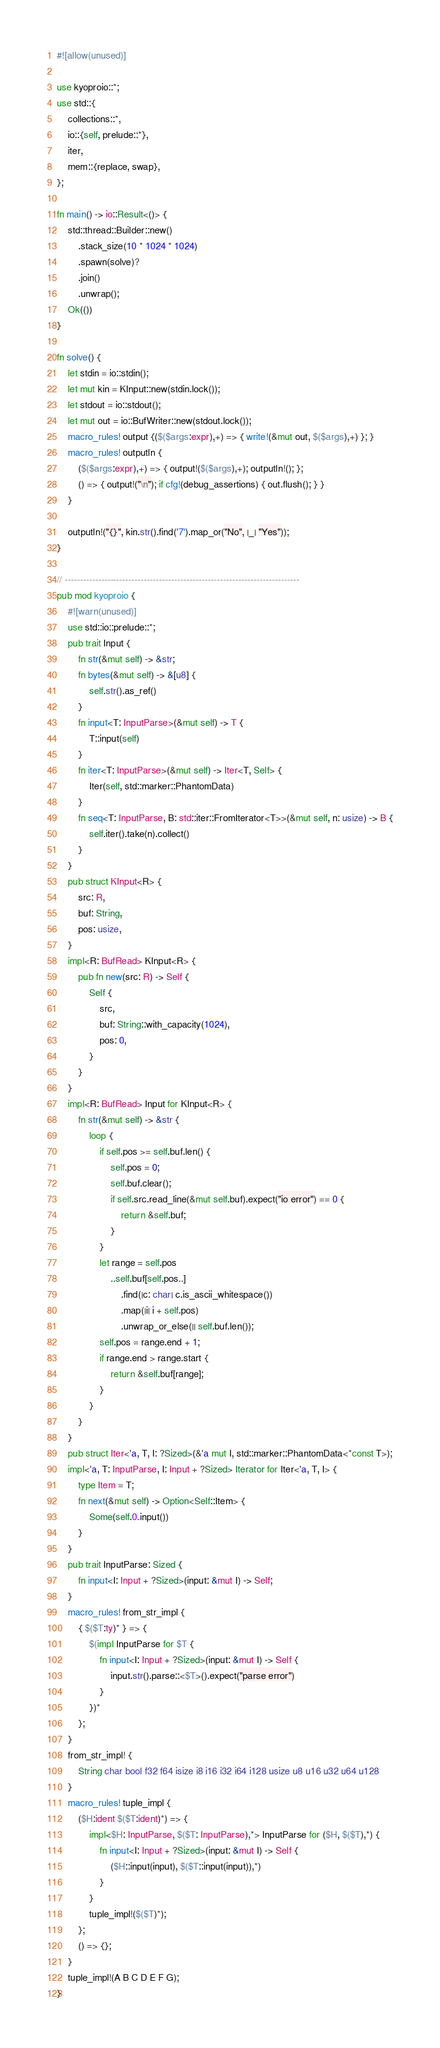<code> <loc_0><loc_0><loc_500><loc_500><_Rust_>#![allow(unused)]

use kyoproio::*;
use std::{
    collections::*,
    io::{self, prelude::*},
    iter,
    mem::{replace, swap},
};

fn main() -> io::Result<()> {
    std::thread::Builder::new()
        .stack_size(10 * 1024 * 1024)
        .spawn(solve)?
        .join()
        .unwrap();
    Ok(())
}

fn solve() {
    let stdin = io::stdin();
    let mut kin = KInput::new(stdin.lock());
    let stdout = io::stdout();
    let mut out = io::BufWriter::new(stdout.lock());
    macro_rules! output {($($args:expr),+) => { write!(&mut out, $($args),+) }; }
    macro_rules! outputln {
        ($($args:expr),+) => { output!($($args),+); outputln!(); };
        () => { output!("\n"); if cfg!(debug_assertions) { out.flush(); } }
    }

    outputln!("{}", kin.str().find('7').map_or("No", |_| "Yes"));
}

// -----------------------------------------------------------------------------
pub mod kyoproio {
    #![warn(unused)]
    use std::io::prelude::*;
    pub trait Input {
        fn str(&mut self) -> &str;
        fn bytes(&mut self) -> &[u8] {
            self.str().as_ref()
        }
        fn input<T: InputParse>(&mut self) -> T {
            T::input(self)
        }
        fn iter<T: InputParse>(&mut self) -> Iter<T, Self> {
            Iter(self, std::marker::PhantomData)
        }
        fn seq<T: InputParse, B: std::iter::FromIterator<T>>(&mut self, n: usize) -> B {
            self.iter().take(n).collect()
        }
    }
    pub struct KInput<R> {
        src: R,
        buf: String,
        pos: usize,
    }
    impl<R: BufRead> KInput<R> {
        pub fn new(src: R) -> Self {
            Self {
                src,
                buf: String::with_capacity(1024),
                pos: 0,
            }
        }
    }
    impl<R: BufRead> Input for KInput<R> {
        fn str(&mut self) -> &str {
            loop {
                if self.pos >= self.buf.len() {
                    self.pos = 0;
                    self.buf.clear();
                    if self.src.read_line(&mut self.buf).expect("io error") == 0 {
                        return &self.buf;
                    }
                }
                let range = self.pos
                    ..self.buf[self.pos..]
                        .find(|c: char| c.is_ascii_whitespace())
                        .map(|i| i + self.pos)
                        .unwrap_or_else(|| self.buf.len());
                self.pos = range.end + 1;
                if range.end > range.start {
                    return &self.buf[range];
                }
            }
        }
    }
    pub struct Iter<'a, T, I: ?Sized>(&'a mut I, std::marker::PhantomData<*const T>);
    impl<'a, T: InputParse, I: Input + ?Sized> Iterator for Iter<'a, T, I> {
        type Item = T;
        fn next(&mut self) -> Option<Self::Item> {
            Some(self.0.input())
        }
    }
    pub trait InputParse: Sized {
        fn input<I: Input + ?Sized>(input: &mut I) -> Self;
    }
    macro_rules! from_str_impl {
        { $($T:ty)* } => {
            $(impl InputParse for $T {
                fn input<I: Input + ?Sized>(input: &mut I) -> Self {
                    input.str().parse::<$T>().expect("parse error")
                }
            })*
        };
    }
    from_str_impl! {
        String char bool f32 f64 isize i8 i16 i32 i64 i128 usize u8 u16 u32 u64 u128
    }
    macro_rules! tuple_impl {
        ($H:ident $($T:ident)*) => {
            impl<$H: InputParse, $($T: InputParse),*> InputParse for ($H, $($T),*) {
                fn input<I: Input + ?Sized>(input: &mut I) -> Self {
                    ($H::input(input), $($T::input(input)),*)
                }
            }
            tuple_impl!($($T)*);
        };
        () => {};
    }
    tuple_impl!(A B C D E F G);
}
</code> 